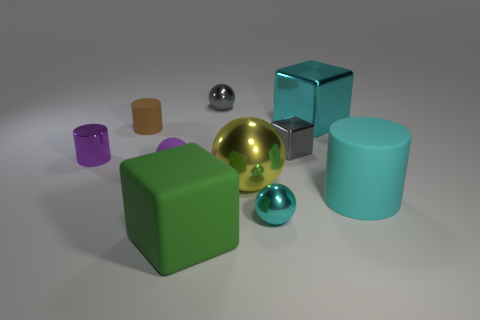What color is the big object that is made of the same material as the big green block?
Keep it short and to the point. Cyan. There is a large yellow object that is the same shape as the tiny purple rubber object; what is its material?
Your answer should be compact. Metal. What is the shape of the small cyan thing?
Offer a very short reply. Sphere. What is the cylinder that is both in front of the brown thing and left of the green thing made of?
Your answer should be compact. Metal. There is a tiny purple object that is the same material as the big green object; what shape is it?
Make the answer very short. Sphere. There is a yellow sphere that is the same material as the tiny cyan ball; what is its size?
Offer a terse response. Large. The small metallic thing that is both to the left of the big yellow thing and in front of the small brown matte cylinder has what shape?
Provide a short and direct response. Cylinder. There is a cyan sphere right of the large cube that is in front of the tiny cyan thing; what is its size?
Offer a very short reply. Small. What number of other objects are there of the same color as the shiny cylinder?
Your answer should be compact. 1. What material is the big cyan block?
Provide a short and direct response. Metal. 